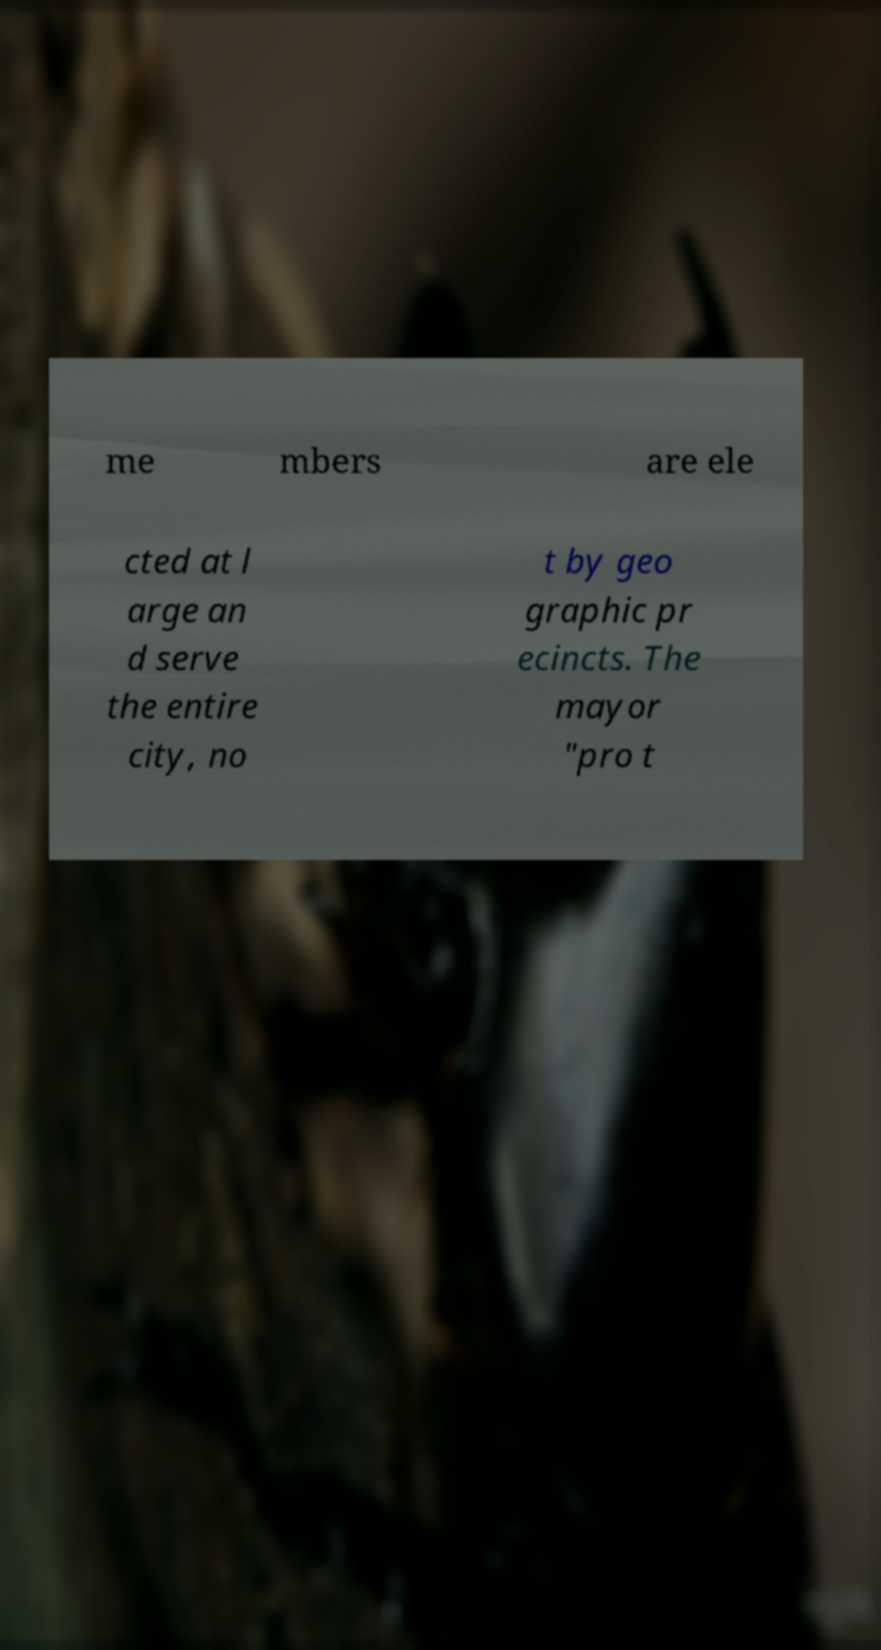Can you read and provide the text displayed in the image?This photo seems to have some interesting text. Can you extract and type it out for me? me mbers are ele cted at l arge an d serve the entire city, no t by geo graphic pr ecincts. The mayor "pro t 